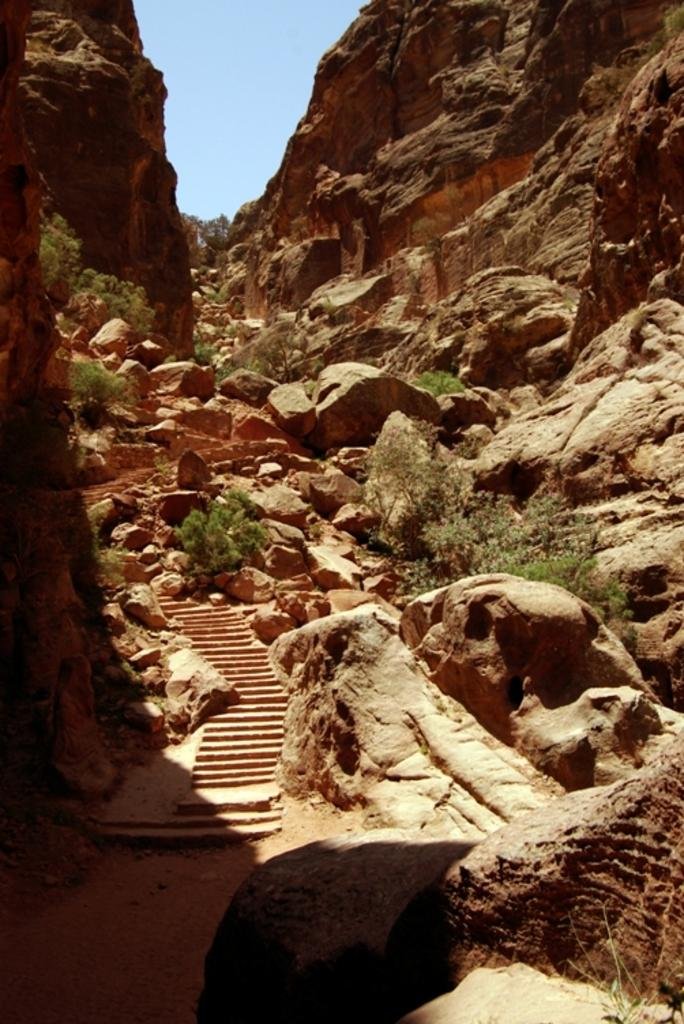What type of landscape feature is located on the right side of the image? There is a hill on the right side of the image. What can be found at the bottom of the hill? Rocks and stones are at the bottom of the hill. What else is present in the middle of the image? There are plants in the middle of the image. What is visible at the top of the image? The sky is visible at the top of the image. What type of advertisement can be seen on the hill in the image? There is no advertisement present on the hill in the image. How many beads are scattered around the plants in the image? There are no beads present in the image. 